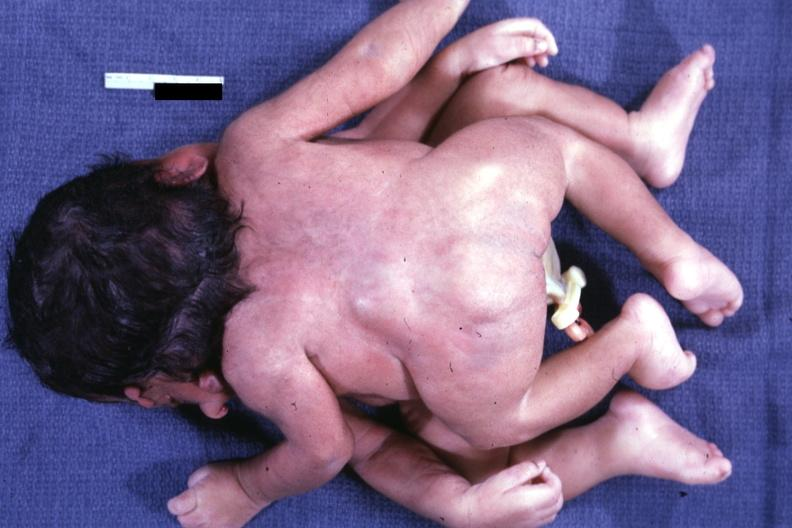what joined at head facing each other?
Answer the question using a single word or phrase. Twins 